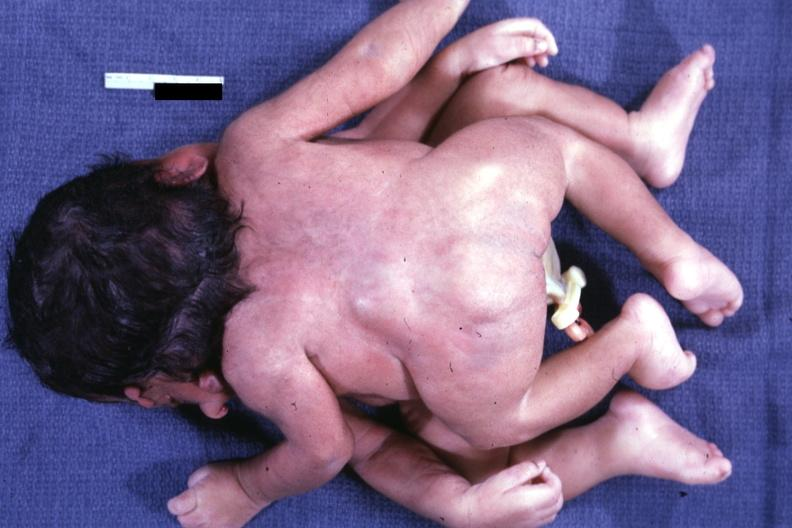what joined at head facing each other?
Answer the question using a single word or phrase. Twins 